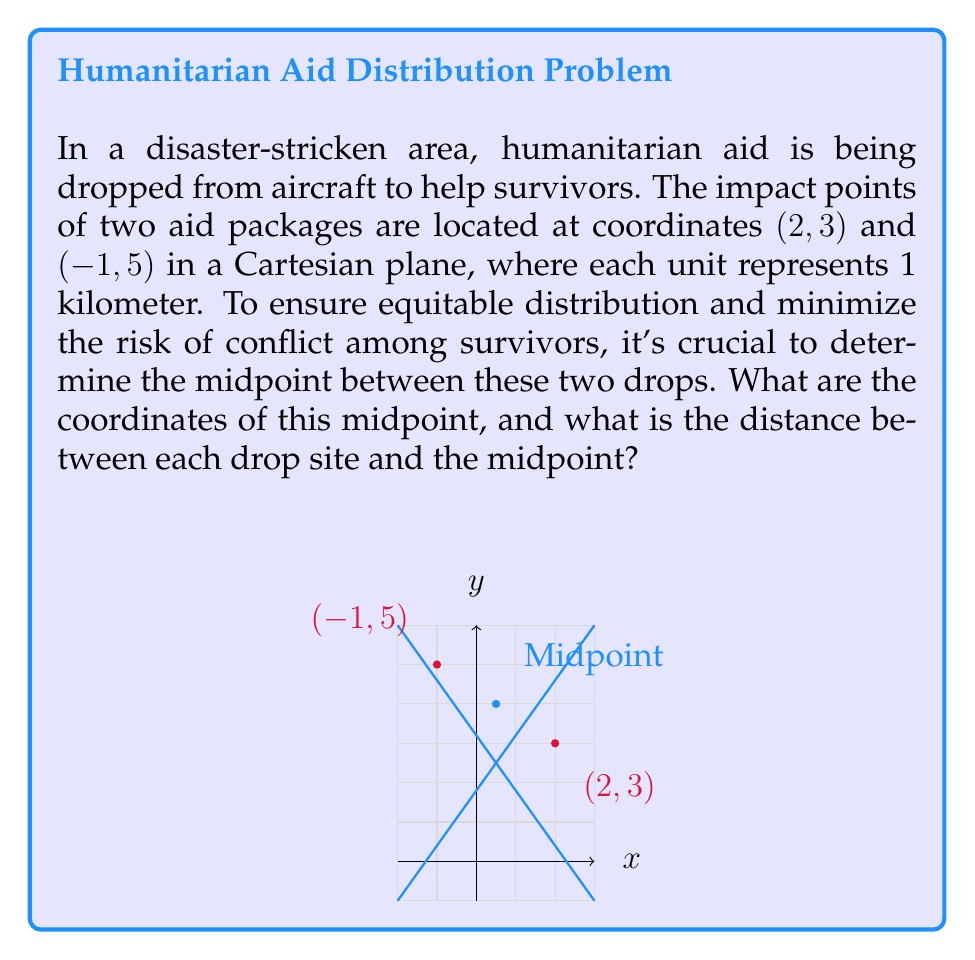Can you solve this math problem? Let's approach this step-by-step:

1. To find the midpoint between two points $(x_1, y_1)$ and $(x_2, y_2)$, we use the midpoint formula:

   $$ \left(\frac{x_1 + x_2}{2}, \frac{y_1 + y_2}{2}\right) $$

2. In this case, $(x_1, y_1) = (2, 3)$ and $(x_2, y_2) = (-1, 5)$. Let's substitute these values:

   $$ \left(\frac{2 + (-1)}{2}, \frac{3 + 5}{2}\right) $$

3. Simplifying:

   $$ \left(\frac{1}{2}, \frac{8}{2}\right) = (0.5, 4) $$

4. Now, to find the distance between each drop site and the midpoint, we can use the distance formula:

   $$ d = \sqrt{(x_2 - x_1)^2 + (y_2 - y_1)^2} $$

5. For the first drop site (2, 3) to the midpoint (0.5, 4):

   $$ d_1 = \sqrt{(0.5 - 2)^2 + (4 - 3)^2} = \sqrt{(-1.5)^2 + 1^2} = \sqrt{2.25 + 1} = \sqrt{3.25} \approx 1.80 km $$

6. For the second drop site (-1, 5) to the midpoint (0.5, 4):

   $$ d_2 = \sqrt{(0.5 - (-1))^2 + (4 - 5)^2} = \sqrt{1.5^2 + (-1)^2} = \sqrt{2.25 + 1} = \sqrt{3.25} \approx 1.80 km $$

The distances are the same, which is expected as the midpoint is equidistant from both drop sites.
Answer: Midpoint: (0.5, 4); Distance from each drop site to midpoint: $\sqrt{3.25} \approx 1.80$ km 